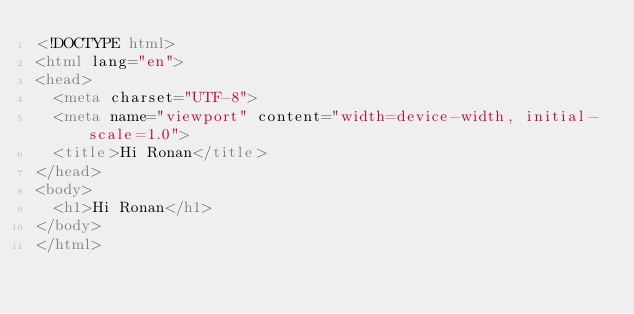<code> <loc_0><loc_0><loc_500><loc_500><_HTML_><!DOCTYPE html>
<html lang="en">
<head>
  <meta charset="UTF-8">
  <meta name="viewport" content="width=device-width, initial-scale=1.0">
  <title>Hi Ronan</title>
</head>
<body>
  <h1>Hi Ronan</h1>
</body>
</html></code> 